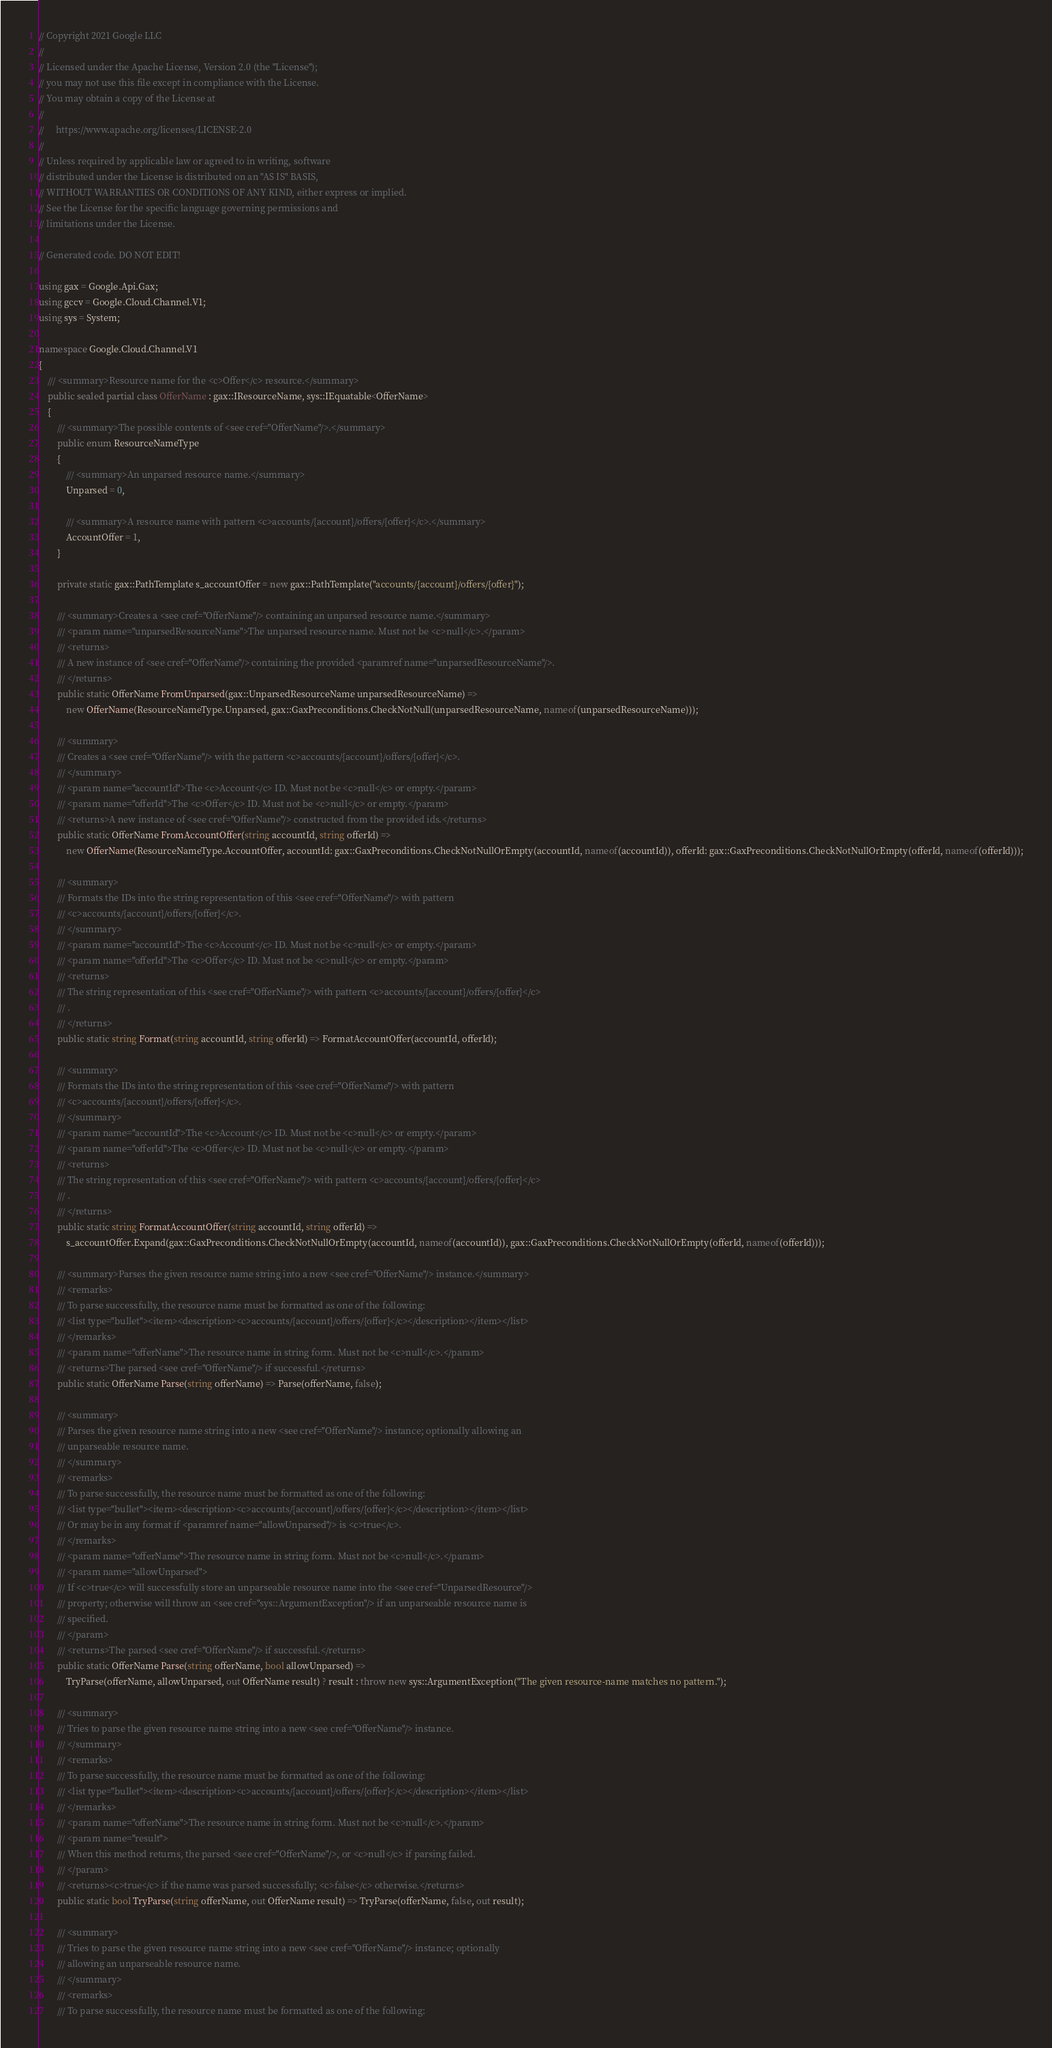<code> <loc_0><loc_0><loc_500><loc_500><_C#_>// Copyright 2021 Google LLC
//
// Licensed under the Apache License, Version 2.0 (the "License");
// you may not use this file except in compliance with the License.
// You may obtain a copy of the License at
//
//     https://www.apache.org/licenses/LICENSE-2.0
//
// Unless required by applicable law or agreed to in writing, software
// distributed under the License is distributed on an "AS IS" BASIS,
// WITHOUT WARRANTIES OR CONDITIONS OF ANY KIND, either express or implied.
// See the License for the specific language governing permissions and
// limitations under the License.

// Generated code. DO NOT EDIT!

using gax = Google.Api.Gax;
using gccv = Google.Cloud.Channel.V1;
using sys = System;

namespace Google.Cloud.Channel.V1
{
    /// <summary>Resource name for the <c>Offer</c> resource.</summary>
    public sealed partial class OfferName : gax::IResourceName, sys::IEquatable<OfferName>
    {
        /// <summary>The possible contents of <see cref="OfferName"/>.</summary>
        public enum ResourceNameType
        {
            /// <summary>An unparsed resource name.</summary>
            Unparsed = 0,

            /// <summary>A resource name with pattern <c>accounts/{account}/offers/{offer}</c>.</summary>
            AccountOffer = 1,
        }

        private static gax::PathTemplate s_accountOffer = new gax::PathTemplate("accounts/{account}/offers/{offer}");

        /// <summary>Creates a <see cref="OfferName"/> containing an unparsed resource name.</summary>
        /// <param name="unparsedResourceName">The unparsed resource name. Must not be <c>null</c>.</param>
        /// <returns>
        /// A new instance of <see cref="OfferName"/> containing the provided <paramref name="unparsedResourceName"/>.
        /// </returns>
        public static OfferName FromUnparsed(gax::UnparsedResourceName unparsedResourceName) =>
            new OfferName(ResourceNameType.Unparsed, gax::GaxPreconditions.CheckNotNull(unparsedResourceName, nameof(unparsedResourceName)));

        /// <summary>
        /// Creates a <see cref="OfferName"/> with the pattern <c>accounts/{account}/offers/{offer}</c>.
        /// </summary>
        /// <param name="accountId">The <c>Account</c> ID. Must not be <c>null</c> or empty.</param>
        /// <param name="offerId">The <c>Offer</c> ID. Must not be <c>null</c> or empty.</param>
        /// <returns>A new instance of <see cref="OfferName"/> constructed from the provided ids.</returns>
        public static OfferName FromAccountOffer(string accountId, string offerId) =>
            new OfferName(ResourceNameType.AccountOffer, accountId: gax::GaxPreconditions.CheckNotNullOrEmpty(accountId, nameof(accountId)), offerId: gax::GaxPreconditions.CheckNotNullOrEmpty(offerId, nameof(offerId)));

        /// <summary>
        /// Formats the IDs into the string representation of this <see cref="OfferName"/> with pattern
        /// <c>accounts/{account}/offers/{offer}</c>.
        /// </summary>
        /// <param name="accountId">The <c>Account</c> ID. Must not be <c>null</c> or empty.</param>
        /// <param name="offerId">The <c>Offer</c> ID. Must not be <c>null</c> or empty.</param>
        /// <returns>
        /// The string representation of this <see cref="OfferName"/> with pattern <c>accounts/{account}/offers/{offer}</c>
        /// .
        /// </returns>
        public static string Format(string accountId, string offerId) => FormatAccountOffer(accountId, offerId);

        /// <summary>
        /// Formats the IDs into the string representation of this <see cref="OfferName"/> with pattern
        /// <c>accounts/{account}/offers/{offer}</c>.
        /// </summary>
        /// <param name="accountId">The <c>Account</c> ID. Must not be <c>null</c> or empty.</param>
        /// <param name="offerId">The <c>Offer</c> ID. Must not be <c>null</c> or empty.</param>
        /// <returns>
        /// The string representation of this <see cref="OfferName"/> with pattern <c>accounts/{account}/offers/{offer}</c>
        /// .
        /// </returns>
        public static string FormatAccountOffer(string accountId, string offerId) =>
            s_accountOffer.Expand(gax::GaxPreconditions.CheckNotNullOrEmpty(accountId, nameof(accountId)), gax::GaxPreconditions.CheckNotNullOrEmpty(offerId, nameof(offerId)));

        /// <summary>Parses the given resource name string into a new <see cref="OfferName"/> instance.</summary>
        /// <remarks>
        /// To parse successfully, the resource name must be formatted as one of the following:
        /// <list type="bullet"><item><description><c>accounts/{account}/offers/{offer}</c></description></item></list>
        /// </remarks>
        /// <param name="offerName">The resource name in string form. Must not be <c>null</c>.</param>
        /// <returns>The parsed <see cref="OfferName"/> if successful.</returns>
        public static OfferName Parse(string offerName) => Parse(offerName, false);

        /// <summary>
        /// Parses the given resource name string into a new <see cref="OfferName"/> instance; optionally allowing an
        /// unparseable resource name.
        /// </summary>
        /// <remarks>
        /// To parse successfully, the resource name must be formatted as one of the following:
        /// <list type="bullet"><item><description><c>accounts/{account}/offers/{offer}</c></description></item></list>
        /// Or may be in any format if <paramref name="allowUnparsed"/> is <c>true</c>.
        /// </remarks>
        /// <param name="offerName">The resource name in string form. Must not be <c>null</c>.</param>
        /// <param name="allowUnparsed">
        /// If <c>true</c> will successfully store an unparseable resource name into the <see cref="UnparsedResource"/>
        /// property; otherwise will throw an <see cref="sys::ArgumentException"/> if an unparseable resource name is
        /// specified.
        /// </param>
        /// <returns>The parsed <see cref="OfferName"/> if successful.</returns>
        public static OfferName Parse(string offerName, bool allowUnparsed) =>
            TryParse(offerName, allowUnparsed, out OfferName result) ? result : throw new sys::ArgumentException("The given resource-name matches no pattern.");

        /// <summary>
        /// Tries to parse the given resource name string into a new <see cref="OfferName"/> instance.
        /// </summary>
        /// <remarks>
        /// To parse successfully, the resource name must be formatted as one of the following:
        /// <list type="bullet"><item><description><c>accounts/{account}/offers/{offer}</c></description></item></list>
        /// </remarks>
        /// <param name="offerName">The resource name in string form. Must not be <c>null</c>.</param>
        /// <param name="result">
        /// When this method returns, the parsed <see cref="OfferName"/>, or <c>null</c> if parsing failed.
        /// </param>
        /// <returns><c>true</c> if the name was parsed successfully; <c>false</c> otherwise.</returns>
        public static bool TryParse(string offerName, out OfferName result) => TryParse(offerName, false, out result);

        /// <summary>
        /// Tries to parse the given resource name string into a new <see cref="OfferName"/> instance; optionally
        /// allowing an unparseable resource name.
        /// </summary>
        /// <remarks>
        /// To parse successfully, the resource name must be formatted as one of the following:</code> 